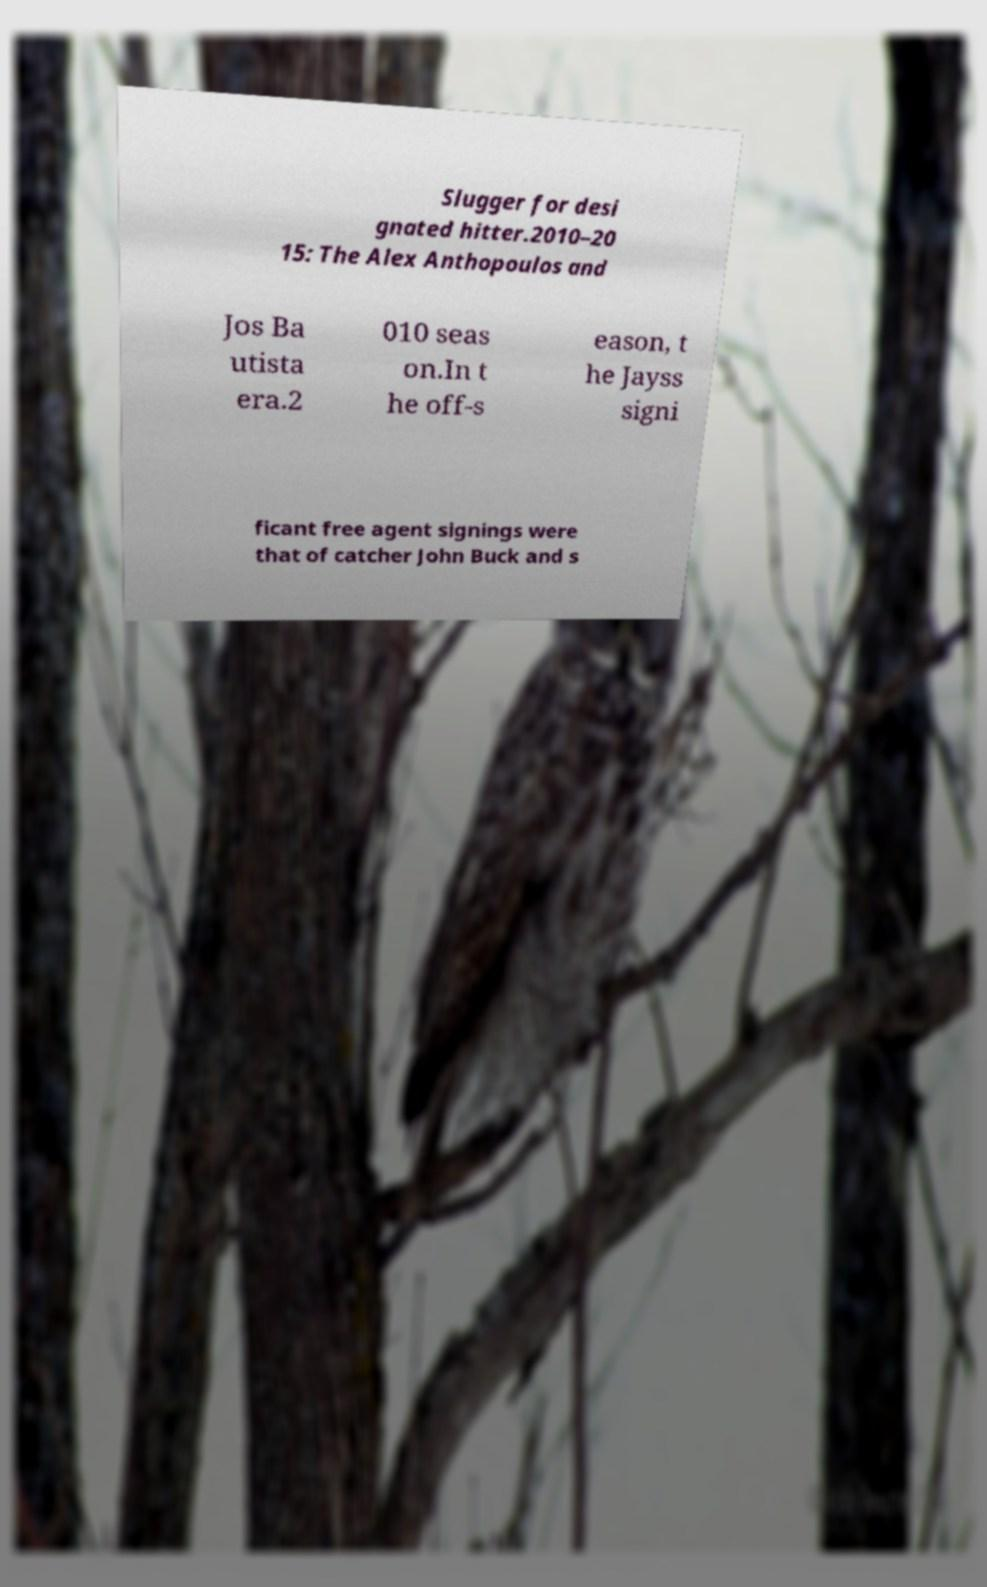Please identify and transcribe the text found in this image. Slugger for desi gnated hitter.2010–20 15: The Alex Anthopoulos and Jos Ba utista era.2 010 seas on.In t he off-s eason, t he Jayss signi ficant free agent signings were that of catcher John Buck and s 